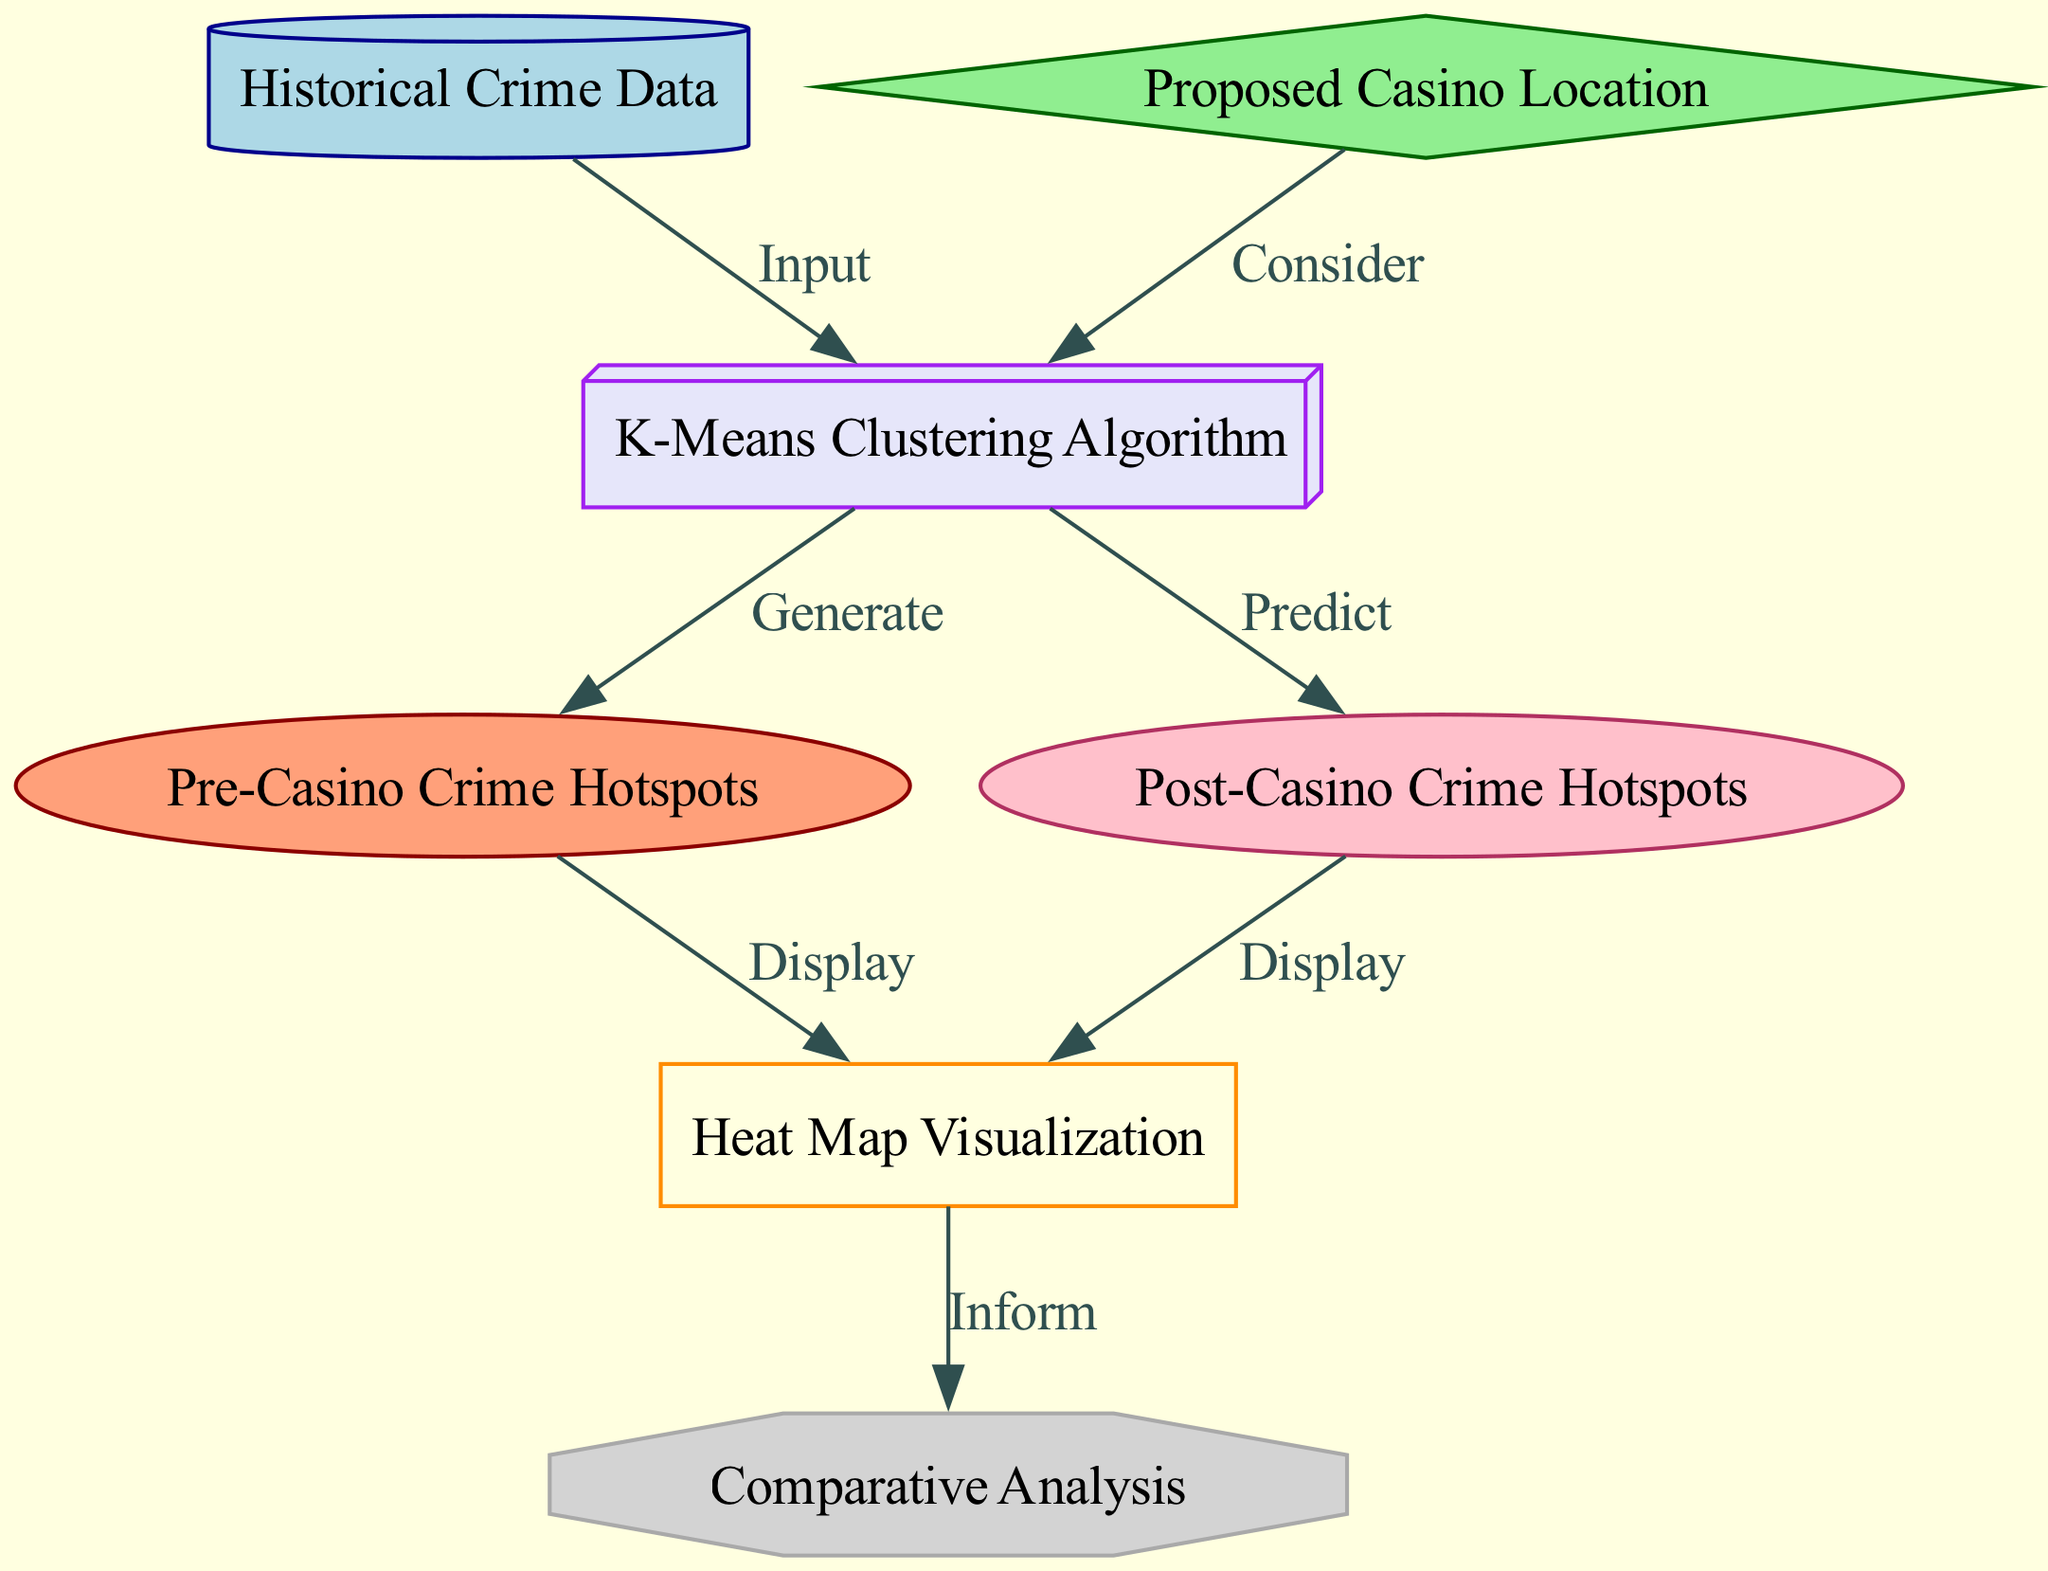What is the main input to the K-Means clustering algorithm? The diagram indicates that the main input to the K-Means clustering algorithm is the "Historical Crime Data," as it flows directly into the K-Means node.
Answer: Historical Crime Data How many nodes are present in the diagram? By counting the distinct nodes listed in the diagram, there are a total of seven nodes: Historical Crime Data, Proposed Casino Location, K-Means Clustering Algorithm, Pre-Casino Crime Hotspots, Post-Casino Crime Hotspots, Heat Map Visualization, and Comparative Analysis.
Answer: Seven What type of relationship exists between the Proposed Casino Location and the K-Means Clustering Algorithm? The arrow in the diagram shows that the Proposed Casino Location is considered by the K-Means Clustering Algorithm, which indicates a "Consider" relationship.
Answer: Consider What is displayed as a result of the Pre-Casino Crime Hotspots? The diagram shows that the output from the Pre-Casino Crime Hotspots is displayed in the Heat Map Visualization, indicating that these hotspots are represented visually after being generated.
Answer: Heat Map Visualization What does the Comparative Analysis inform? The diagram clearly indicates that the output from the Heat Map Visualization is used to inform the Comparative Analysis, demonstrating that this analysis is based on the visualized data of crime hotspots.
Answer: Inform What is predicted by the K-Means Clustering Algorithm concerning the Post-Casino Crime Hotspots? The diagram describes that after considering the input data, the K-Means Clustering Algorithm predicts the Post-Casino Crime Hotspots, marking it as an output of the algorithm.
Answer: Predict What color represents the K-Means Clustering Algorithm node in the diagram? Looking at the node's properties as per the diagram, the K-Means Clustering Algorithm is represented in lavender color as indicated by its fillcolor attribute.
Answer: Lavender What type of node is the Proposed Casino Location? According to the diagram's notation, the Proposed Casino Location is depicted as a diamond shape, which categorically defines its node type.
Answer: Diamond 